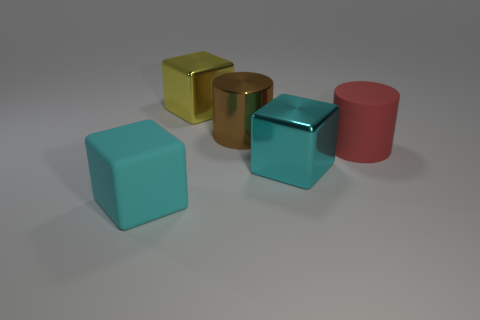Add 1 rubber cylinders. How many objects exist? 6 Subtract all blocks. How many objects are left? 2 Subtract 0 blue cubes. How many objects are left? 5 Subtract all big red matte objects. Subtract all blocks. How many objects are left? 1 Add 1 big red matte cylinders. How many big red matte cylinders are left? 2 Add 3 purple things. How many purple things exist? 3 